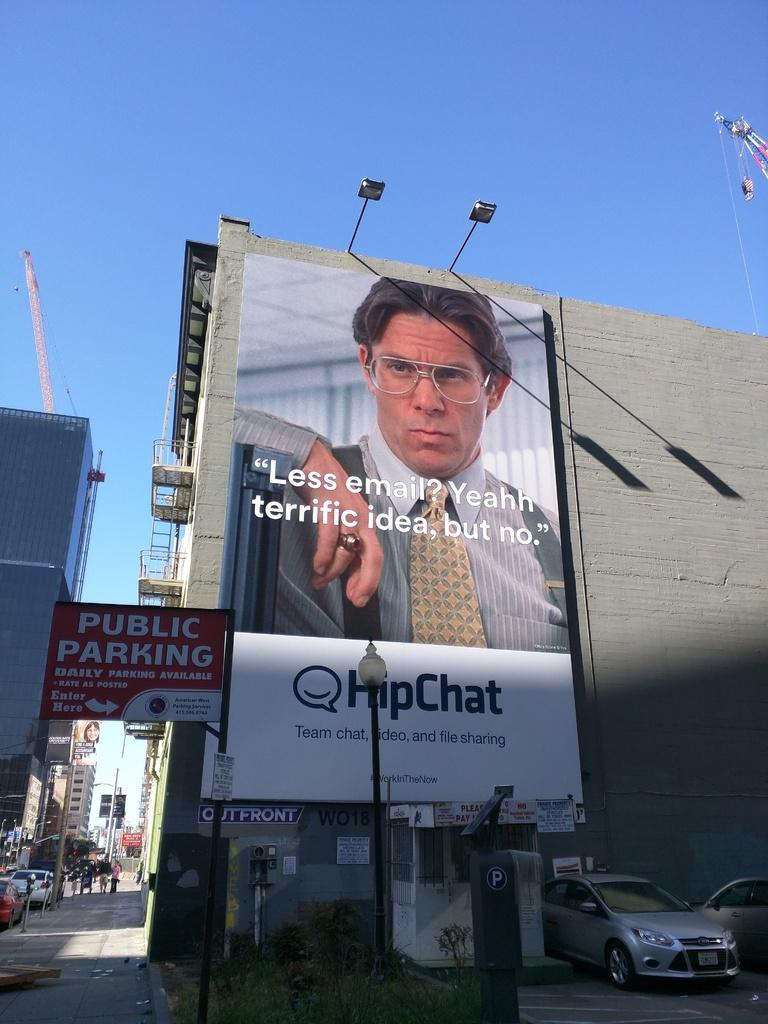<image>
Describe the image concisely. A big billboard has the guy from Office Space and says Less email, yeahh terrific idea, but no. 